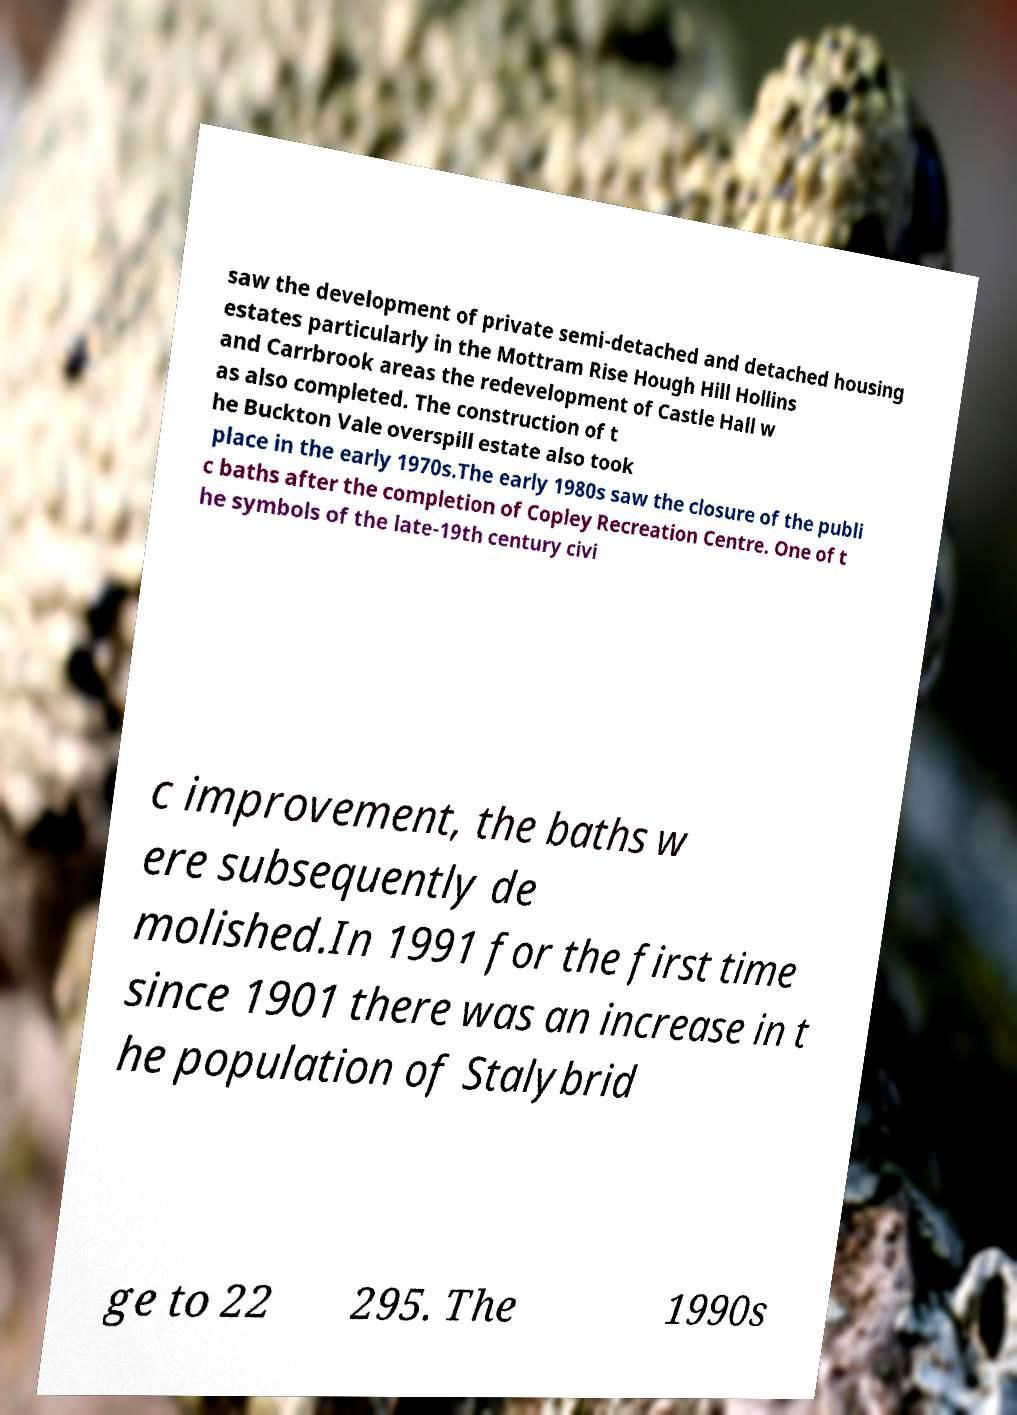There's text embedded in this image that I need extracted. Can you transcribe it verbatim? saw the development of private semi-detached and detached housing estates particularly in the Mottram Rise Hough Hill Hollins and Carrbrook areas the redevelopment of Castle Hall w as also completed. The construction of t he Buckton Vale overspill estate also took place in the early 1970s.The early 1980s saw the closure of the publi c baths after the completion of Copley Recreation Centre. One of t he symbols of the late-19th century civi c improvement, the baths w ere subsequently de molished.In 1991 for the first time since 1901 there was an increase in t he population of Stalybrid ge to 22 295. The 1990s 